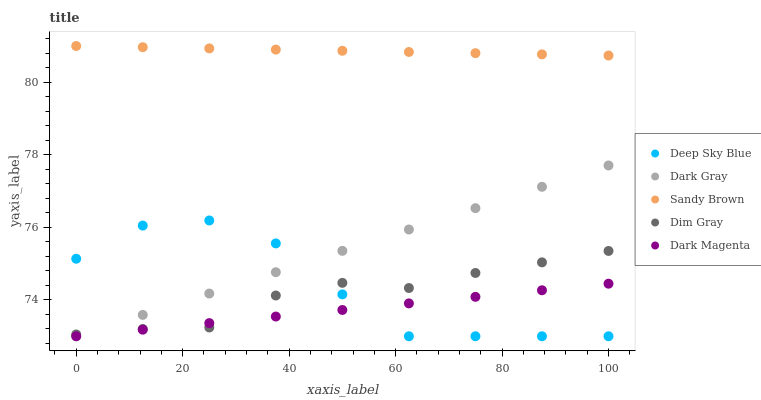Does Dark Magenta have the minimum area under the curve?
Answer yes or no. Yes. Does Sandy Brown have the maximum area under the curve?
Answer yes or no. Yes. Does Dim Gray have the minimum area under the curve?
Answer yes or no. No. Does Dim Gray have the maximum area under the curve?
Answer yes or no. No. Is Dark Magenta the smoothest?
Answer yes or no. Yes. Is Deep Sky Blue the roughest?
Answer yes or no. Yes. Is Dim Gray the smoothest?
Answer yes or no. No. Is Dim Gray the roughest?
Answer yes or no. No. Does Dark Gray have the lowest value?
Answer yes or no. Yes. Does Dim Gray have the lowest value?
Answer yes or no. No. Does Sandy Brown have the highest value?
Answer yes or no. Yes. Does Dim Gray have the highest value?
Answer yes or no. No. Is Dim Gray less than Sandy Brown?
Answer yes or no. Yes. Is Sandy Brown greater than Dark Magenta?
Answer yes or no. Yes. Does Dark Gray intersect Deep Sky Blue?
Answer yes or no. Yes. Is Dark Gray less than Deep Sky Blue?
Answer yes or no. No. Is Dark Gray greater than Deep Sky Blue?
Answer yes or no. No. Does Dim Gray intersect Sandy Brown?
Answer yes or no. No. 